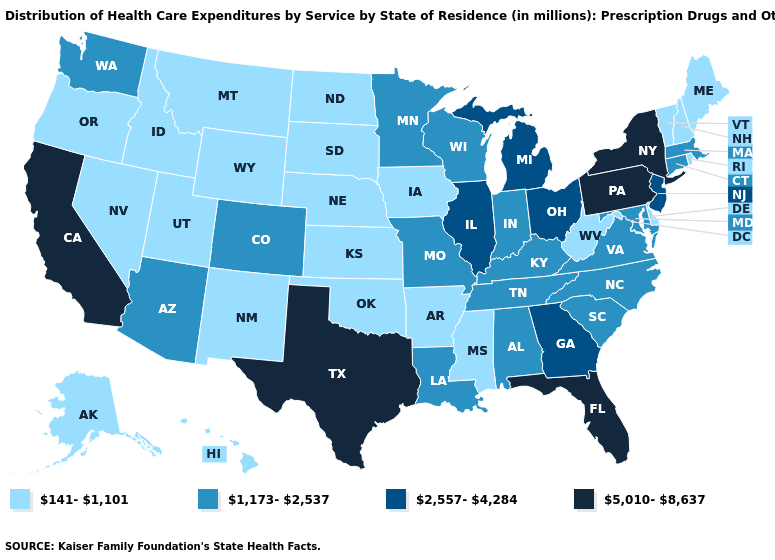Among the states that border Pennsylvania , does New Jersey have the highest value?
Give a very brief answer. No. Name the states that have a value in the range 141-1,101?
Be succinct. Alaska, Arkansas, Delaware, Hawaii, Idaho, Iowa, Kansas, Maine, Mississippi, Montana, Nebraska, Nevada, New Hampshire, New Mexico, North Dakota, Oklahoma, Oregon, Rhode Island, South Dakota, Utah, Vermont, West Virginia, Wyoming. Is the legend a continuous bar?
Give a very brief answer. No. Name the states that have a value in the range 2,557-4,284?
Concise answer only. Georgia, Illinois, Michigan, New Jersey, Ohio. Is the legend a continuous bar?
Short answer required. No. Does Oklahoma have the highest value in the USA?
Write a very short answer. No. What is the highest value in the Northeast ?
Be succinct. 5,010-8,637. What is the value of Washington?
Write a very short answer. 1,173-2,537. Which states have the lowest value in the USA?
Keep it brief. Alaska, Arkansas, Delaware, Hawaii, Idaho, Iowa, Kansas, Maine, Mississippi, Montana, Nebraska, Nevada, New Hampshire, New Mexico, North Dakota, Oklahoma, Oregon, Rhode Island, South Dakota, Utah, Vermont, West Virginia, Wyoming. Does the first symbol in the legend represent the smallest category?
Be succinct. Yes. Which states hav the highest value in the MidWest?
Give a very brief answer. Illinois, Michigan, Ohio. How many symbols are there in the legend?
Write a very short answer. 4. What is the value of Kansas?
Short answer required. 141-1,101. Name the states that have a value in the range 1,173-2,537?
Write a very short answer. Alabama, Arizona, Colorado, Connecticut, Indiana, Kentucky, Louisiana, Maryland, Massachusetts, Minnesota, Missouri, North Carolina, South Carolina, Tennessee, Virginia, Washington, Wisconsin. What is the value of Washington?
Be succinct. 1,173-2,537. 